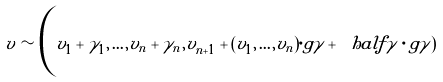<formula> <loc_0><loc_0><loc_500><loc_500>v \sim \Big ( v _ { 1 } + \gamma _ { 1 } , \dots , v _ { n } + \gamma _ { n } , v _ { n + 1 } + ( v _ { 1 } , \dots , v _ { n } ) \cdot g \gamma + \ h a l f \gamma \cdot g \gamma )</formula> 